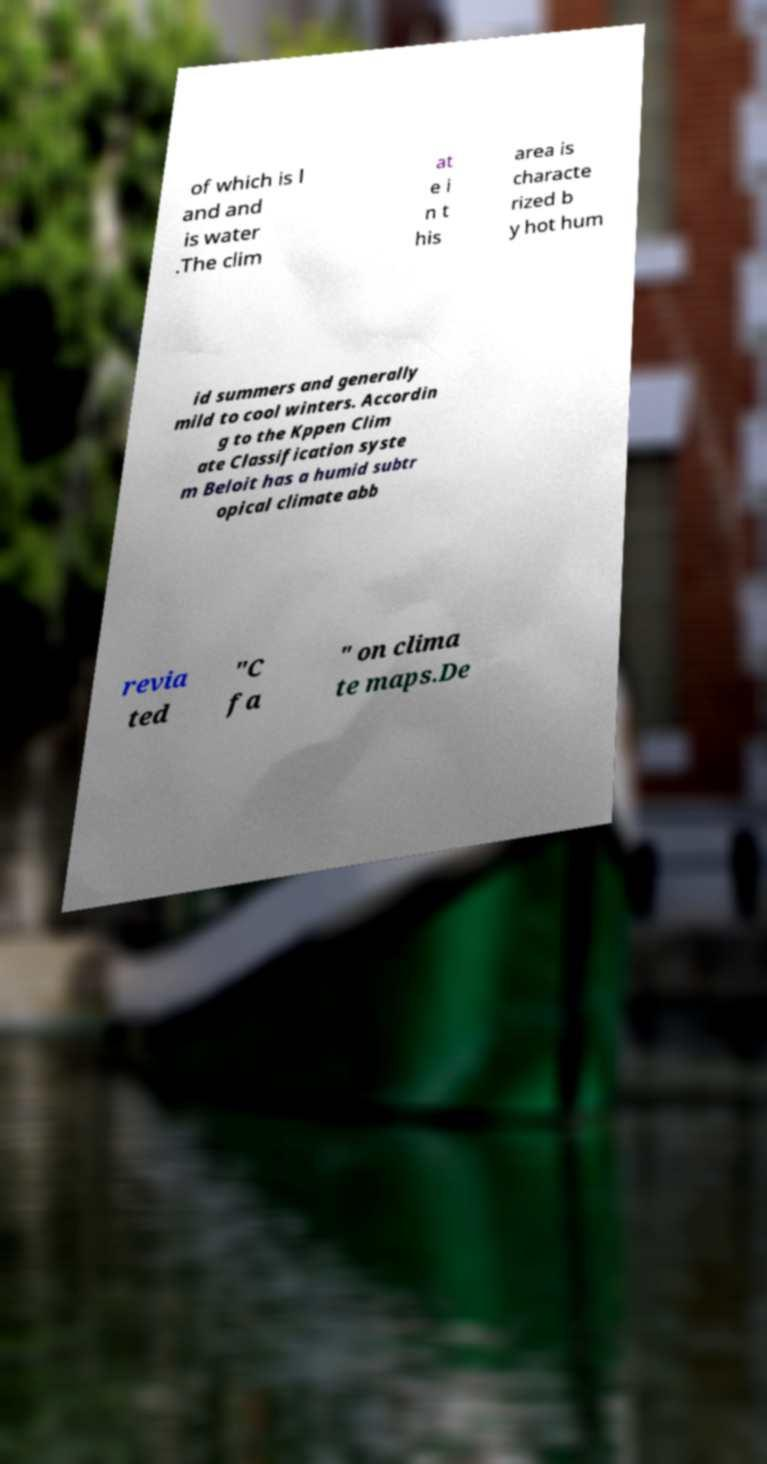Could you extract and type out the text from this image? of which is l and and is water .The clim at e i n t his area is characte rized b y hot hum id summers and generally mild to cool winters. Accordin g to the Kppen Clim ate Classification syste m Beloit has a humid subtr opical climate abb revia ted "C fa " on clima te maps.De 